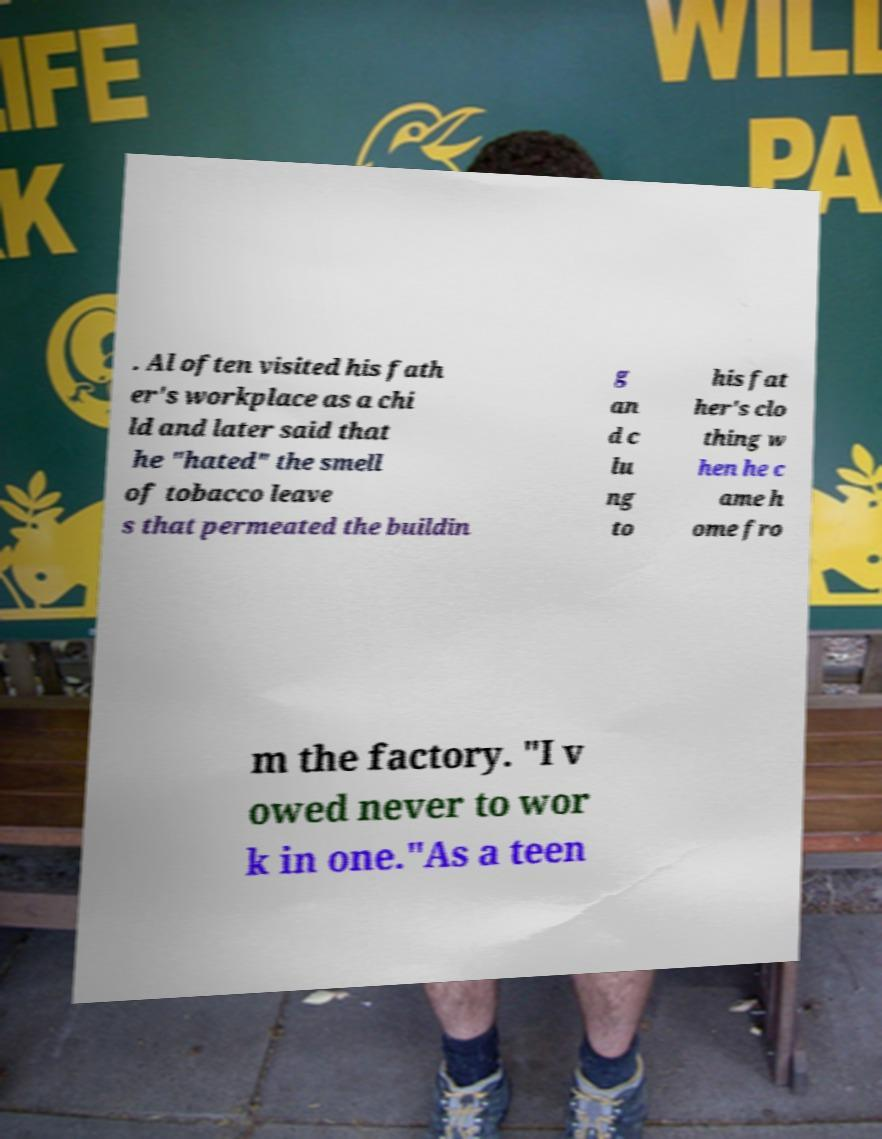What messages or text are displayed in this image? I need them in a readable, typed format. . Al often visited his fath er's workplace as a chi ld and later said that he "hated" the smell of tobacco leave s that permeated the buildin g an d c lu ng to his fat her's clo thing w hen he c ame h ome fro m the factory. "I v owed never to wor k in one."As a teen 